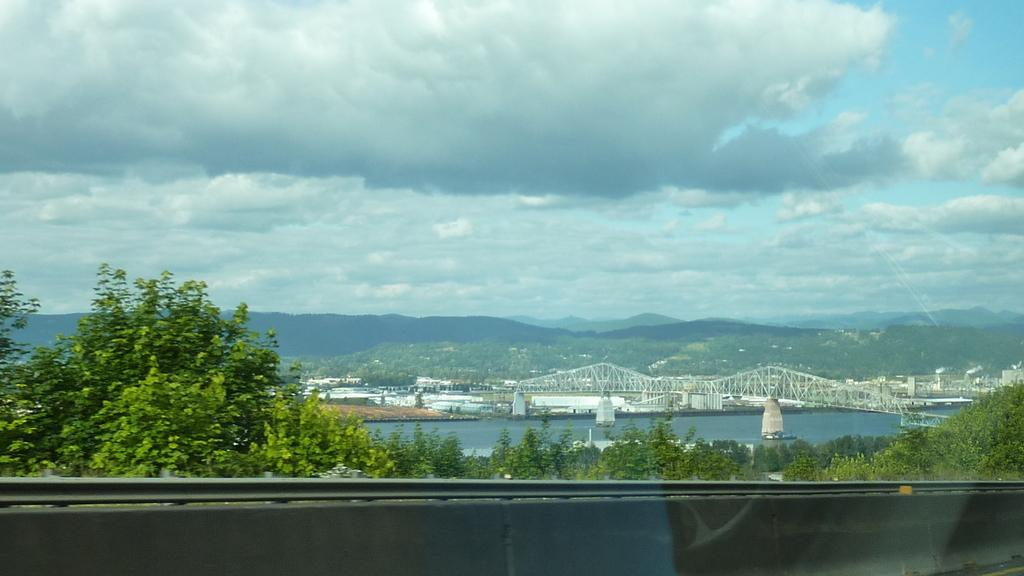What type of vegetation can be seen in the image? There are trees in the image. What type of structure is present in the image? There is a bridge in the image. What natural element is visible in the image? There is water visible in the image. What part of the natural environment is visible in the image? The sky is visible in the image. What song is being sung by the giants in the image? There are no giants or any indication of singing in the image. How many lines can be seen on the bridge in the image? The image does not provide enough detail to determine the number of lines on the bridge. 